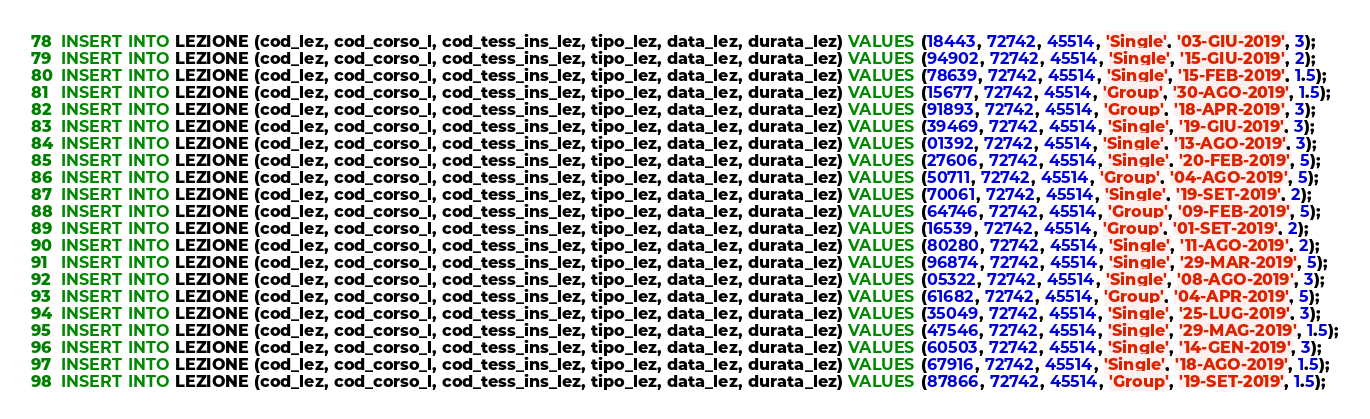Convert code to text. <code><loc_0><loc_0><loc_500><loc_500><_SQL_>INSERT INTO LEZIONE (cod_lez, cod_corso_l, cod_tess_ins_lez, tipo_lez, data_lez, durata_lez) VALUES (18443, 72742, 45514, 'Single', '03-GIU-2019', 3);
INSERT INTO LEZIONE (cod_lez, cod_corso_l, cod_tess_ins_lez, tipo_lez, data_lez, durata_lez) VALUES (94902, 72742, 45514, 'Single', '15-GIU-2019', 2);
INSERT INTO LEZIONE (cod_lez, cod_corso_l, cod_tess_ins_lez, tipo_lez, data_lez, durata_lez) VALUES (78639, 72742, 45514, 'Single', '15-FEB-2019', 1.5);
INSERT INTO LEZIONE (cod_lez, cod_corso_l, cod_tess_ins_lez, tipo_lez, data_lez, durata_lez) VALUES (15677, 72742, 45514, 'Group', '30-AGO-2019', 1.5);
INSERT INTO LEZIONE (cod_lez, cod_corso_l, cod_tess_ins_lez, tipo_lez, data_lez, durata_lez) VALUES (91893, 72742, 45514, 'Group', '18-APR-2019', 3);
INSERT INTO LEZIONE (cod_lez, cod_corso_l, cod_tess_ins_lez, tipo_lez, data_lez, durata_lez) VALUES (39469, 72742, 45514, 'Single', '19-GIU-2019', 3);
INSERT INTO LEZIONE (cod_lez, cod_corso_l, cod_tess_ins_lez, tipo_lez, data_lez, durata_lez) VALUES (01392, 72742, 45514, 'Single', '13-AGO-2019', 3);
INSERT INTO LEZIONE (cod_lez, cod_corso_l, cod_tess_ins_lez, tipo_lez, data_lez, durata_lez) VALUES (27606, 72742, 45514, 'Single', '20-FEB-2019', 5);
INSERT INTO LEZIONE (cod_lez, cod_corso_l, cod_tess_ins_lez, tipo_lez, data_lez, durata_lez) VALUES (50711, 72742, 45514, 'Group', '04-AGO-2019', 5);
INSERT INTO LEZIONE (cod_lez, cod_corso_l, cod_tess_ins_lez, tipo_lez, data_lez, durata_lez) VALUES (70061, 72742, 45514, 'Single', '19-SET-2019', 2);
INSERT INTO LEZIONE (cod_lez, cod_corso_l, cod_tess_ins_lez, tipo_lez, data_lez, durata_lez) VALUES (64746, 72742, 45514, 'Group', '09-FEB-2019', 5);
INSERT INTO LEZIONE (cod_lez, cod_corso_l, cod_tess_ins_lez, tipo_lez, data_lez, durata_lez) VALUES (16539, 72742, 45514, 'Group', '01-SET-2019', 2);
INSERT INTO LEZIONE (cod_lez, cod_corso_l, cod_tess_ins_lez, tipo_lez, data_lez, durata_lez) VALUES (80280, 72742, 45514, 'Single', '11-AGO-2019', 2);
INSERT INTO LEZIONE (cod_lez, cod_corso_l, cod_tess_ins_lez, tipo_lez, data_lez, durata_lez) VALUES (96874, 72742, 45514, 'Single', '29-MAR-2019', 5);
INSERT INTO LEZIONE (cod_lez, cod_corso_l, cod_tess_ins_lez, tipo_lez, data_lez, durata_lez) VALUES (05322, 72742, 45514, 'Single', '08-AGO-2019', 3);
INSERT INTO LEZIONE (cod_lez, cod_corso_l, cod_tess_ins_lez, tipo_lez, data_lez, durata_lez) VALUES (61682, 72742, 45514, 'Group', '04-APR-2019', 5);
INSERT INTO LEZIONE (cod_lez, cod_corso_l, cod_tess_ins_lez, tipo_lez, data_lez, durata_lez) VALUES (35049, 72742, 45514, 'Single', '25-LUG-2019', 3);
INSERT INTO LEZIONE (cod_lez, cod_corso_l, cod_tess_ins_lez, tipo_lez, data_lez, durata_lez) VALUES (47546, 72742, 45514, 'Single', '29-MAG-2019', 1.5);
INSERT INTO LEZIONE (cod_lez, cod_corso_l, cod_tess_ins_lez, tipo_lez, data_lez, durata_lez) VALUES (60503, 72742, 45514, 'Single', '14-GEN-2019', 3);
INSERT INTO LEZIONE (cod_lez, cod_corso_l, cod_tess_ins_lez, tipo_lez, data_lez, durata_lez) VALUES (67916, 72742, 45514, 'Single', '18-AGO-2019', 1.5);
INSERT INTO LEZIONE (cod_lez, cod_corso_l, cod_tess_ins_lez, tipo_lez, data_lez, durata_lez) VALUES (87866, 72742, 45514, 'Group', '19-SET-2019', 1.5);</code> 